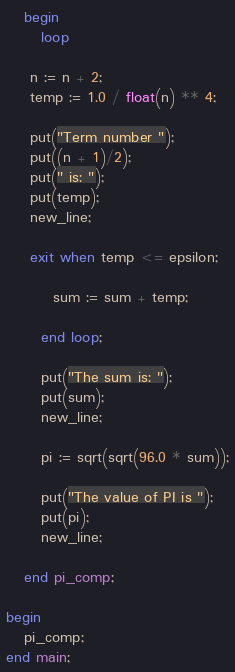<code> <loc_0><loc_0><loc_500><loc_500><_Ada_>
   begin
      loop

	n := n + 2;
	temp := 1.0 / float(n) ** 4;

	put("Term number ");
	put((n + 1)/2);
	put(" is: ");
	put(temp);
	new_line;

	exit when temp <= epsilon;

        sum := sum + temp;

      end loop;

      put("The sum is: ");
      put(sum);
      new_line;

      pi := sqrt(sqrt(96.0 * sum));

      put("The value of PI is ");
      put(pi);
      new_line;

   end pi_comp;

begin
   pi_comp;
end main;
</code> 